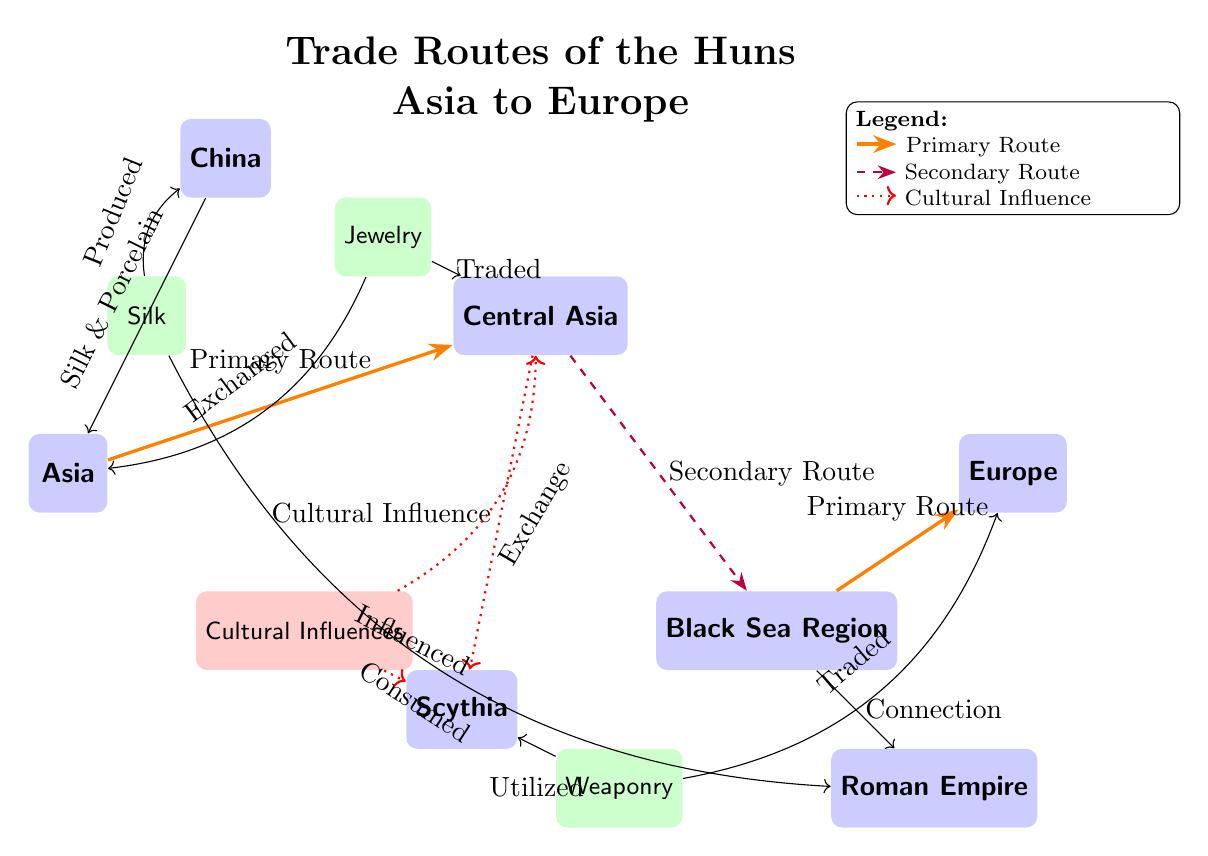How many primary trade routes are shown in the diagram? The diagram indicates two primary trade routes, one connecting Asia to Central Asia and the other connecting Black Sea to Europe.
Answer: 2 What goods are produced in China according to the diagram? According to the diagram, the goods produced in China include Silk and Porcelain, as indicated by the arrow directing from China to Asia.
Answer: Silk & Porcelain Which region receives weaponry as indicated in the diagram? The diagram shows that weaponry is utilized in Scythia and traded to Europe, indicating that both regions receive it.
Answer: Scythia and Europe What is the total number of goods indicated in the diagram? The diagram shows three distinct goods: Silk, Jewelry, and Weaponry, making a total of three goods represented.
Answer: 3 Which cultural influences are indicated in the diagram? The diagram indicates that Cultural Influences flow from Central Asia to Scythia and also influences Scythia directly, highlighting cultural exchange.
Answer: Cultural Influences Which route connects Central Asia to the Black Sea? The diagram denotes that the secondary route connects Central Asia to the Black Sea, specified by the dashed purple line between the two regions.
Answer: Secondary Route What kind of connection does the Black Sea have to the Roman Empire? The diagram states that there is a connection from the Black Sea to the Roman Empire, shown through a directed arrow labeled "Connection."
Answer: Connection Which good is exchanged between Asia and Central Asia? The diagram indicates that Jewelry is exchanged from Asia to Central Asia, as shown by the arrow indicating the direction of the trade.
Answer: Jewelry What does the legend describe about primary routes? The legend in the diagram describes primary routes as lines drawn in orange, indicating the significance of these routes in trade pathways.
Answer: Primary Route What influences flow from Central Asia to Scythia? The diagram illustrates that cultural influences flow from Central Asia to Scythia, as represented by the red dotted arrow indicating influence.
Answer: Cultural Influence 